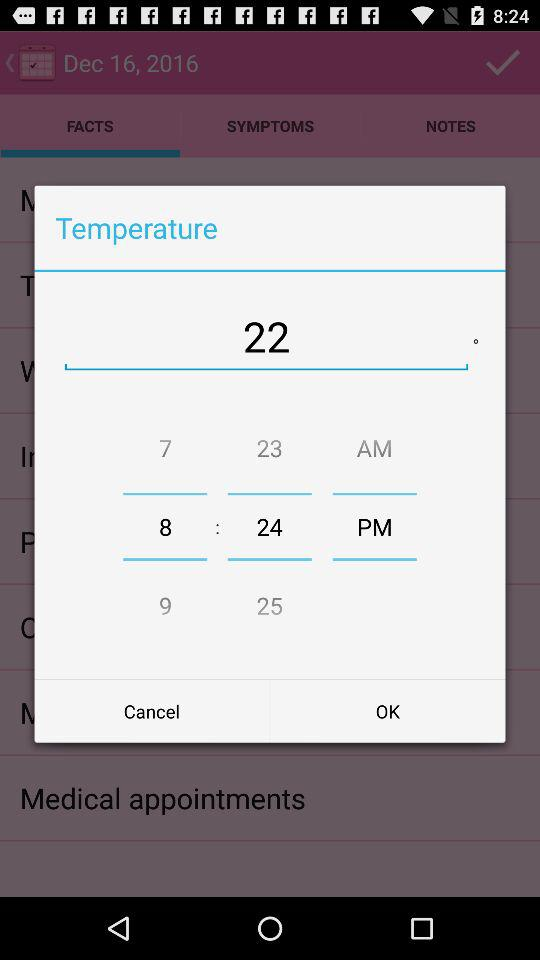What is the selected temperature? The selected temperature is 22 degrees. 